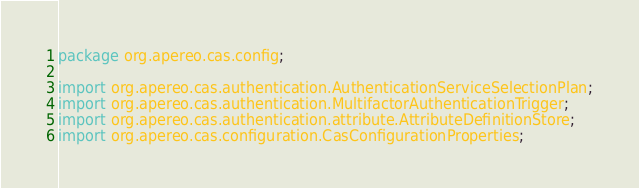Convert code to text. <code><loc_0><loc_0><loc_500><loc_500><_Java_>package org.apereo.cas.config;

import org.apereo.cas.authentication.AuthenticationServiceSelectionPlan;
import org.apereo.cas.authentication.MultifactorAuthenticationTrigger;
import org.apereo.cas.authentication.attribute.AttributeDefinitionStore;
import org.apereo.cas.configuration.CasConfigurationProperties;</code> 